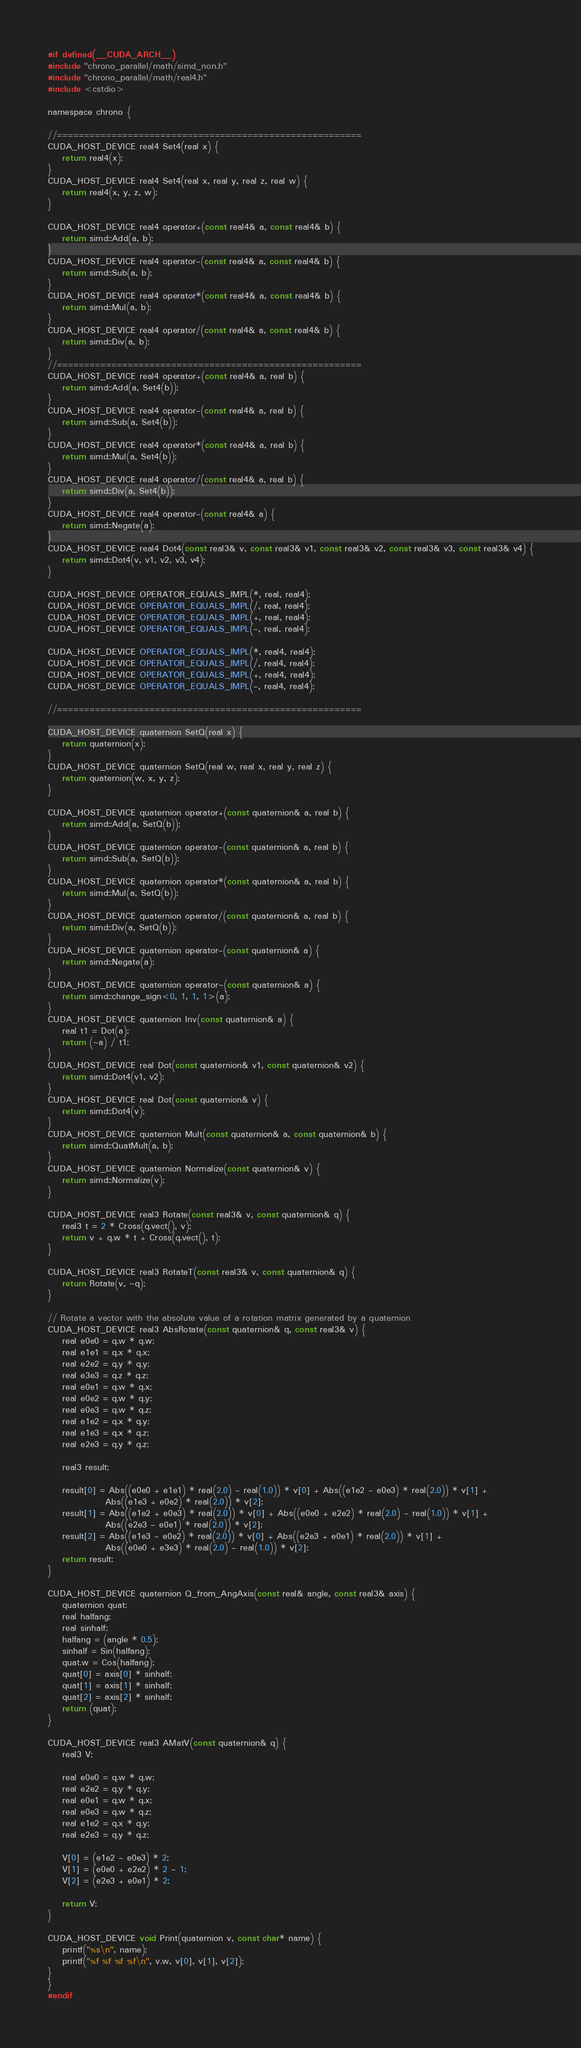<code> <loc_0><loc_0><loc_500><loc_500><_Cuda_>#if defined(__CUDA_ARCH__)
#include "chrono_parallel/math/simd_non.h"
#include "chrono_parallel/math/real4.h"
#include <cstdio>

namespace chrono {

//========================================================
CUDA_HOST_DEVICE real4 Set4(real x) {
    return real4(x);
}
CUDA_HOST_DEVICE real4 Set4(real x, real y, real z, real w) {
    return real4(x, y, z, w);
}

CUDA_HOST_DEVICE real4 operator+(const real4& a, const real4& b) {
    return simd::Add(a, b);
}
CUDA_HOST_DEVICE real4 operator-(const real4& a, const real4& b) {
    return simd::Sub(a, b);
}
CUDA_HOST_DEVICE real4 operator*(const real4& a, const real4& b) {
    return simd::Mul(a, b);
}
CUDA_HOST_DEVICE real4 operator/(const real4& a, const real4& b) {
    return simd::Div(a, b);
}
//========================================================
CUDA_HOST_DEVICE real4 operator+(const real4& a, real b) {
    return simd::Add(a, Set4(b));
}
CUDA_HOST_DEVICE real4 operator-(const real4& a, real b) {
    return simd::Sub(a, Set4(b));
}
CUDA_HOST_DEVICE real4 operator*(const real4& a, real b) {
    return simd::Mul(a, Set4(b));
}
CUDA_HOST_DEVICE real4 operator/(const real4& a, real b) {
    return simd::Div(a, Set4(b));
}
CUDA_HOST_DEVICE real4 operator-(const real4& a) {
    return simd::Negate(a);
}
CUDA_HOST_DEVICE real4 Dot4(const real3& v, const real3& v1, const real3& v2, const real3& v3, const real3& v4) {
    return simd::Dot4(v, v1, v2, v3, v4);
}

CUDA_HOST_DEVICE OPERATOR_EQUALS_IMPL(*, real, real4);
CUDA_HOST_DEVICE OPERATOR_EQUALS_IMPL(/, real, real4);
CUDA_HOST_DEVICE OPERATOR_EQUALS_IMPL(+, real, real4);
CUDA_HOST_DEVICE OPERATOR_EQUALS_IMPL(-, real, real4);

CUDA_HOST_DEVICE OPERATOR_EQUALS_IMPL(*, real4, real4);
CUDA_HOST_DEVICE OPERATOR_EQUALS_IMPL(/, real4, real4);
CUDA_HOST_DEVICE OPERATOR_EQUALS_IMPL(+, real4, real4);
CUDA_HOST_DEVICE OPERATOR_EQUALS_IMPL(-, real4, real4);

//========================================================

CUDA_HOST_DEVICE quaternion SetQ(real x) {
    return quaternion(x);
}
CUDA_HOST_DEVICE quaternion SetQ(real w, real x, real y, real z) {
    return quaternion(w, x, y, z);
}

CUDA_HOST_DEVICE quaternion operator+(const quaternion& a, real b) {
    return simd::Add(a, SetQ(b));
}
CUDA_HOST_DEVICE quaternion operator-(const quaternion& a, real b) {
    return simd::Sub(a, SetQ(b));
}
CUDA_HOST_DEVICE quaternion operator*(const quaternion& a, real b) {
    return simd::Mul(a, SetQ(b));
}
CUDA_HOST_DEVICE quaternion operator/(const quaternion& a, real b) {
    return simd::Div(a, SetQ(b));
}
CUDA_HOST_DEVICE quaternion operator-(const quaternion& a) {
    return simd::Negate(a);
}
CUDA_HOST_DEVICE quaternion operator~(const quaternion& a) {
    return simd::change_sign<0, 1, 1, 1>(a);
}
CUDA_HOST_DEVICE quaternion Inv(const quaternion& a) {
    real t1 = Dot(a);
    return (~a) / t1;
}
CUDA_HOST_DEVICE real Dot(const quaternion& v1, const quaternion& v2) {
    return simd::Dot4(v1, v2);
}
CUDA_HOST_DEVICE real Dot(const quaternion& v) {
    return simd::Dot4(v);
}
CUDA_HOST_DEVICE quaternion Mult(const quaternion& a, const quaternion& b) {
    return simd::QuatMult(a, b);
}
CUDA_HOST_DEVICE quaternion Normalize(const quaternion& v) {
    return simd::Normalize(v);
}

CUDA_HOST_DEVICE real3 Rotate(const real3& v, const quaternion& q) {
    real3 t = 2 * Cross(q.vect(), v);
    return v + q.w * t + Cross(q.vect(), t);
}

CUDA_HOST_DEVICE real3 RotateT(const real3& v, const quaternion& q) {
    return Rotate(v, ~q);
}

// Rotate a vector with the absolute value of a rotation matrix generated by a quaternion
CUDA_HOST_DEVICE real3 AbsRotate(const quaternion& q, const real3& v) {
    real e0e0 = q.w * q.w;
    real e1e1 = q.x * q.x;
    real e2e2 = q.y * q.y;
    real e3e3 = q.z * q.z;
    real e0e1 = q.w * q.x;
    real e0e2 = q.w * q.y;
    real e0e3 = q.w * q.z;
    real e1e2 = q.x * q.y;
    real e1e3 = q.x * q.z;
    real e2e3 = q.y * q.z;

    real3 result;

    result[0] = Abs((e0e0 + e1e1) * real(2.0) - real(1.0)) * v[0] + Abs((e1e2 - e0e3) * real(2.0)) * v[1] +
                Abs((e1e3 + e0e2) * real(2.0)) * v[2];
    result[1] = Abs((e1e2 + e0e3) * real(2.0)) * v[0] + Abs((e0e0 + e2e2) * real(2.0) - real(1.0)) * v[1] +
                Abs((e2e3 - e0e1) * real(2.0)) * v[2];
    result[2] = Abs((e1e3 - e0e2) * real(2.0)) * v[0] + Abs((e2e3 + e0e1) * real(2.0)) * v[1] +
                Abs((e0e0 + e3e3) * real(2.0) - real(1.0)) * v[2];
    return result;
}

CUDA_HOST_DEVICE quaternion Q_from_AngAxis(const real& angle, const real3& axis) {
    quaternion quat;
    real halfang;
    real sinhalf;
    halfang = (angle * 0.5);
    sinhalf = Sin(halfang);
    quat.w = Cos(halfang);
    quat[0] = axis[0] * sinhalf;
    quat[1] = axis[1] * sinhalf;
    quat[2] = axis[2] * sinhalf;
    return (quat);
}

CUDA_HOST_DEVICE real3 AMatV(const quaternion& q) {
    real3 V;

    real e0e0 = q.w * q.w;
    real e2e2 = q.y * q.y;
    real e0e1 = q.w * q.x;
    real e0e3 = q.w * q.z;
    real e1e2 = q.x * q.y;
    real e2e3 = q.y * q.z;

    V[0] = (e1e2 - e0e3) * 2;
    V[1] = (e0e0 + e2e2) * 2 - 1;
    V[2] = (e2e3 + e0e1) * 2;

    return V;
}

CUDA_HOST_DEVICE void Print(quaternion v, const char* name) {
    printf("%s\n", name);
    printf("%f %f %f %f\n", v.w, v[0], v[1], v[2]);
}
}
#endif
</code> 